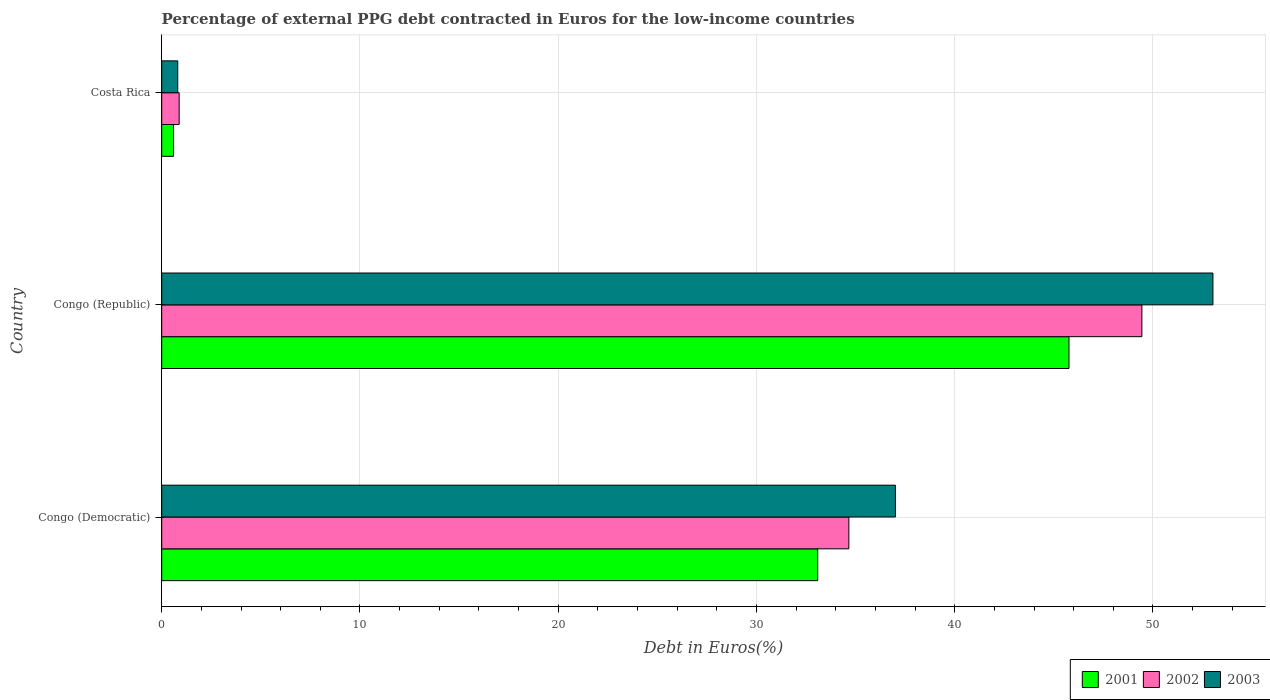Are the number of bars per tick equal to the number of legend labels?
Offer a terse response. Yes. Are the number of bars on each tick of the Y-axis equal?
Your answer should be very brief. Yes. How many bars are there on the 3rd tick from the top?
Your response must be concise. 3. What is the percentage of external PPG debt contracted in Euros in 2002 in Costa Rica?
Make the answer very short. 0.88. Across all countries, what is the maximum percentage of external PPG debt contracted in Euros in 2002?
Provide a succinct answer. 49.44. Across all countries, what is the minimum percentage of external PPG debt contracted in Euros in 2003?
Your response must be concise. 0.81. In which country was the percentage of external PPG debt contracted in Euros in 2001 maximum?
Provide a short and direct response. Congo (Republic). In which country was the percentage of external PPG debt contracted in Euros in 2002 minimum?
Your answer should be compact. Costa Rica. What is the total percentage of external PPG debt contracted in Euros in 2002 in the graph?
Provide a short and direct response. 84.98. What is the difference between the percentage of external PPG debt contracted in Euros in 2003 in Congo (Democratic) and that in Congo (Republic)?
Offer a very short reply. -16.02. What is the difference between the percentage of external PPG debt contracted in Euros in 2002 in Costa Rica and the percentage of external PPG debt contracted in Euros in 2003 in Congo (Democratic)?
Make the answer very short. -36.13. What is the average percentage of external PPG debt contracted in Euros in 2001 per country?
Offer a very short reply. 26.48. What is the difference between the percentage of external PPG debt contracted in Euros in 2001 and percentage of external PPG debt contracted in Euros in 2002 in Congo (Democratic)?
Ensure brevity in your answer.  -1.57. In how many countries, is the percentage of external PPG debt contracted in Euros in 2001 greater than 52 %?
Make the answer very short. 0. What is the ratio of the percentage of external PPG debt contracted in Euros in 2001 in Congo (Republic) to that in Costa Rica?
Your response must be concise. 76.86. Is the percentage of external PPG debt contracted in Euros in 2002 in Congo (Democratic) less than that in Congo (Republic)?
Make the answer very short. Yes. Is the difference between the percentage of external PPG debt contracted in Euros in 2001 in Congo (Democratic) and Costa Rica greater than the difference between the percentage of external PPG debt contracted in Euros in 2002 in Congo (Democratic) and Costa Rica?
Your response must be concise. No. What is the difference between the highest and the second highest percentage of external PPG debt contracted in Euros in 2002?
Provide a succinct answer. 14.78. What is the difference between the highest and the lowest percentage of external PPG debt contracted in Euros in 2002?
Keep it short and to the point. 48.56. In how many countries, is the percentage of external PPG debt contracted in Euros in 2002 greater than the average percentage of external PPG debt contracted in Euros in 2002 taken over all countries?
Make the answer very short. 2. Is the sum of the percentage of external PPG debt contracted in Euros in 2001 in Congo (Republic) and Costa Rica greater than the maximum percentage of external PPG debt contracted in Euros in 2002 across all countries?
Your answer should be very brief. No. What does the 1st bar from the top in Congo (Democratic) represents?
Provide a succinct answer. 2003. What does the 2nd bar from the bottom in Congo (Democratic) represents?
Ensure brevity in your answer.  2002. What is the difference between two consecutive major ticks on the X-axis?
Make the answer very short. 10. Are the values on the major ticks of X-axis written in scientific E-notation?
Give a very brief answer. No. Does the graph contain any zero values?
Provide a short and direct response. No. How many legend labels are there?
Make the answer very short. 3. What is the title of the graph?
Your answer should be very brief. Percentage of external PPG debt contracted in Euros for the low-income countries. What is the label or title of the X-axis?
Offer a terse response. Debt in Euros(%). What is the Debt in Euros(%) in 2001 in Congo (Democratic)?
Ensure brevity in your answer.  33.09. What is the Debt in Euros(%) in 2002 in Congo (Democratic)?
Ensure brevity in your answer.  34.66. What is the Debt in Euros(%) of 2003 in Congo (Democratic)?
Your response must be concise. 37.01. What is the Debt in Euros(%) of 2001 in Congo (Republic)?
Provide a succinct answer. 45.76. What is the Debt in Euros(%) in 2002 in Congo (Republic)?
Your answer should be compact. 49.44. What is the Debt in Euros(%) in 2003 in Congo (Republic)?
Your answer should be very brief. 53.02. What is the Debt in Euros(%) in 2001 in Costa Rica?
Ensure brevity in your answer.  0.6. What is the Debt in Euros(%) in 2002 in Costa Rica?
Your response must be concise. 0.88. What is the Debt in Euros(%) in 2003 in Costa Rica?
Provide a short and direct response. 0.81. Across all countries, what is the maximum Debt in Euros(%) of 2001?
Offer a very short reply. 45.76. Across all countries, what is the maximum Debt in Euros(%) of 2002?
Keep it short and to the point. 49.44. Across all countries, what is the maximum Debt in Euros(%) in 2003?
Offer a very short reply. 53.02. Across all countries, what is the minimum Debt in Euros(%) in 2001?
Your answer should be very brief. 0.6. Across all countries, what is the minimum Debt in Euros(%) in 2003?
Your response must be concise. 0.81. What is the total Debt in Euros(%) in 2001 in the graph?
Keep it short and to the point. 79.45. What is the total Debt in Euros(%) in 2002 in the graph?
Ensure brevity in your answer.  84.98. What is the total Debt in Euros(%) in 2003 in the graph?
Keep it short and to the point. 90.84. What is the difference between the Debt in Euros(%) in 2001 in Congo (Democratic) and that in Congo (Republic)?
Your answer should be very brief. -12.67. What is the difference between the Debt in Euros(%) of 2002 in Congo (Democratic) and that in Congo (Republic)?
Offer a terse response. -14.78. What is the difference between the Debt in Euros(%) of 2003 in Congo (Democratic) and that in Congo (Republic)?
Your answer should be very brief. -16.02. What is the difference between the Debt in Euros(%) of 2001 in Congo (Democratic) and that in Costa Rica?
Your response must be concise. 32.5. What is the difference between the Debt in Euros(%) of 2002 in Congo (Democratic) and that in Costa Rica?
Ensure brevity in your answer.  33.78. What is the difference between the Debt in Euros(%) in 2003 in Congo (Democratic) and that in Costa Rica?
Offer a terse response. 36.2. What is the difference between the Debt in Euros(%) of 2001 in Congo (Republic) and that in Costa Rica?
Make the answer very short. 45.17. What is the difference between the Debt in Euros(%) in 2002 in Congo (Republic) and that in Costa Rica?
Give a very brief answer. 48.56. What is the difference between the Debt in Euros(%) in 2003 in Congo (Republic) and that in Costa Rica?
Ensure brevity in your answer.  52.22. What is the difference between the Debt in Euros(%) in 2001 in Congo (Democratic) and the Debt in Euros(%) in 2002 in Congo (Republic)?
Offer a terse response. -16.35. What is the difference between the Debt in Euros(%) of 2001 in Congo (Democratic) and the Debt in Euros(%) of 2003 in Congo (Republic)?
Offer a very short reply. -19.93. What is the difference between the Debt in Euros(%) of 2002 in Congo (Democratic) and the Debt in Euros(%) of 2003 in Congo (Republic)?
Provide a short and direct response. -18.36. What is the difference between the Debt in Euros(%) in 2001 in Congo (Democratic) and the Debt in Euros(%) in 2002 in Costa Rica?
Provide a short and direct response. 32.21. What is the difference between the Debt in Euros(%) of 2001 in Congo (Democratic) and the Debt in Euros(%) of 2003 in Costa Rica?
Your response must be concise. 32.28. What is the difference between the Debt in Euros(%) in 2002 in Congo (Democratic) and the Debt in Euros(%) in 2003 in Costa Rica?
Ensure brevity in your answer.  33.85. What is the difference between the Debt in Euros(%) of 2001 in Congo (Republic) and the Debt in Euros(%) of 2002 in Costa Rica?
Your answer should be compact. 44.88. What is the difference between the Debt in Euros(%) in 2001 in Congo (Republic) and the Debt in Euros(%) in 2003 in Costa Rica?
Give a very brief answer. 44.95. What is the difference between the Debt in Euros(%) of 2002 in Congo (Republic) and the Debt in Euros(%) of 2003 in Costa Rica?
Your response must be concise. 48.63. What is the average Debt in Euros(%) of 2001 per country?
Your answer should be very brief. 26.48. What is the average Debt in Euros(%) of 2002 per country?
Give a very brief answer. 28.33. What is the average Debt in Euros(%) in 2003 per country?
Offer a very short reply. 30.28. What is the difference between the Debt in Euros(%) of 2001 and Debt in Euros(%) of 2002 in Congo (Democratic)?
Provide a succinct answer. -1.57. What is the difference between the Debt in Euros(%) of 2001 and Debt in Euros(%) of 2003 in Congo (Democratic)?
Keep it short and to the point. -3.92. What is the difference between the Debt in Euros(%) in 2002 and Debt in Euros(%) in 2003 in Congo (Democratic)?
Your response must be concise. -2.35. What is the difference between the Debt in Euros(%) in 2001 and Debt in Euros(%) in 2002 in Congo (Republic)?
Your answer should be compact. -3.68. What is the difference between the Debt in Euros(%) in 2001 and Debt in Euros(%) in 2003 in Congo (Republic)?
Provide a succinct answer. -7.26. What is the difference between the Debt in Euros(%) of 2002 and Debt in Euros(%) of 2003 in Congo (Republic)?
Your response must be concise. -3.58. What is the difference between the Debt in Euros(%) of 2001 and Debt in Euros(%) of 2002 in Costa Rica?
Your answer should be very brief. -0.28. What is the difference between the Debt in Euros(%) of 2001 and Debt in Euros(%) of 2003 in Costa Rica?
Give a very brief answer. -0.21. What is the difference between the Debt in Euros(%) in 2002 and Debt in Euros(%) in 2003 in Costa Rica?
Your response must be concise. 0.07. What is the ratio of the Debt in Euros(%) of 2001 in Congo (Democratic) to that in Congo (Republic)?
Keep it short and to the point. 0.72. What is the ratio of the Debt in Euros(%) of 2002 in Congo (Democratic) to that in Congo (Republic)?
Your answer should be very brief. 0.7. What is the ratio of the Debt in Euros(%) of 2003 in Congo (Democratic) to that in Congo (Republic)?
Ensure brevity in your answer.  0.7. What is the ratio of the Debt in Euros(%) of 2001 in Congo (Democratic) to that in Costa Rica?
Provide a short and direct response. 55.58. What is the ratio of the Debt in Euros(%) in 2002 in Congo (Democratic) to that in Costa Rica?
Your answer should be compact. 39.39. What is the ratio of the Debt in Euros(%) in 2003 in Congo (Democratic) to that in Costa Rica?
Offer a very short reply. 45.76. What is the ratio of the Debt in Euros(%) in 2001 in Congo (Republic) to that in Costa Rica?
Provide a short and direct response. 76.86. What is the ratio of the Debt in Euros(%) of 2002 in Congo (Republic) to that in Costa Rica?
Keep it short and to the point. 56.18. What is the ratio of the Debt in Euros(%) of 2003 in Congo (Republic) to that in Costa Rica?
Keep it short and to the point. 65.56. What is the difference between the highest and the second highest Debt in Euros(%) of 2001?
Your answer should be very brief. 12.67. What is the difference between the highest and the second highest Debt in Euros(%) in 2002?
Provide a short and direct response. 14.78. What is the difference between the highest and the second highest Debt in Euros(%) of 2003?
Give a very brief answer. 16.02. What is the difference between the highest and the lowest Debt in Euros(%) of 2001?
Your response must be concise. 45.17. What is the difference between the highest and the lowest Debt in Euros(%) of 2002?
Provide a succinct answer. 48.56. What is the difference between the highest and the lowest Debt in Euros(%) in 2003?
Keep it short and to the point. 52.22. 